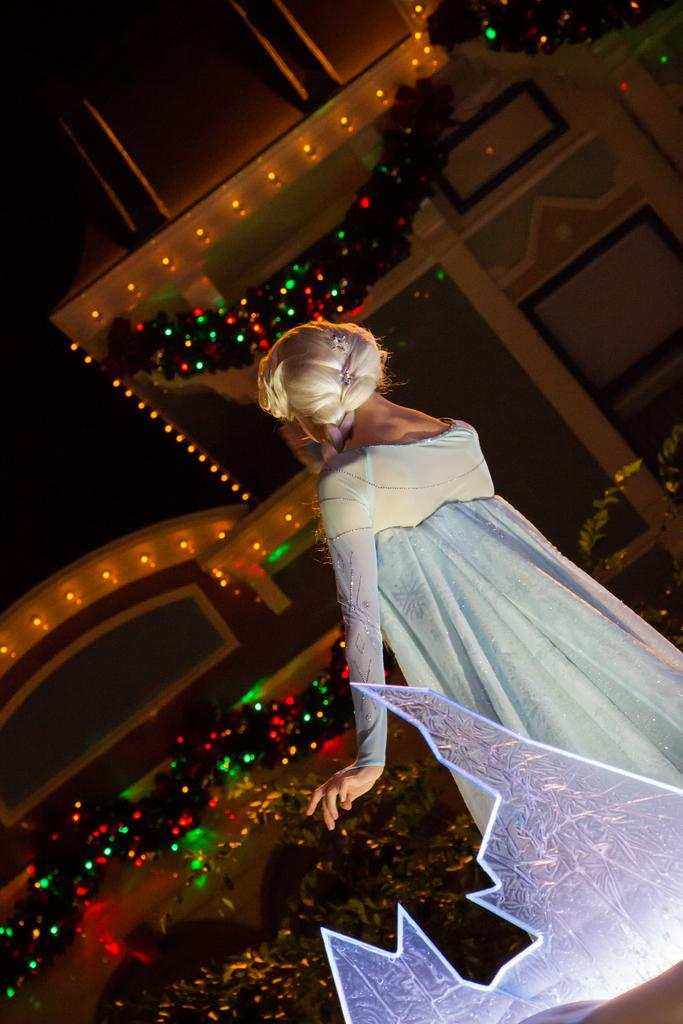What can be seen on the walls in the image? The walls in the image are decorated with lights and decorative items. Can you describe the person in the image? There is a woman in the image. What is the woman wearing? The woman is wearing a dress. What is the woman's posture in the image? The woman is standing. How many bikes are parked next to the woman in the image? There are no bikes present in the image. What type of goose is sitting on the woman's shoulder in the image? There is no goose present in the image. 